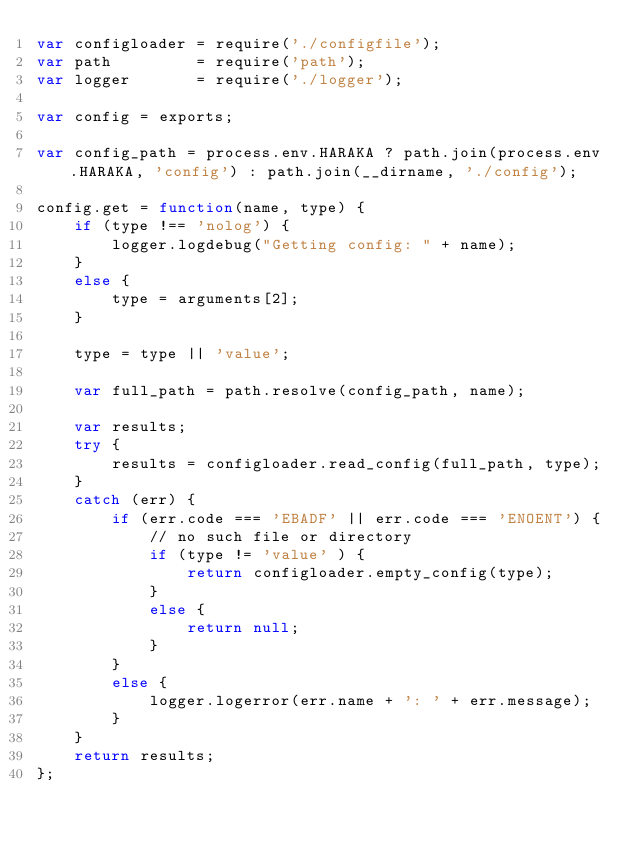Convert code to text. <code><loc_0><loc_0><loc_500><loc_500><_JavaScript_>var configloader = require('./configfile');
var path         = require('path');
var logger       = require('./logger');

var config = exports;

var config_path = process.env.HARAKA ? path.join(process.env.HARAKA, 'config') : path.join(__dirname, './config');

config.get = function(name, type) {
    if (type !== 'nolog') {
        logger.logdebug("Getting config: " + name);
    }
    else {
        type = arguments[2];
    }
    
    type = type || 'value';
    
    var full_path = path.resolve(config_path, name);
    
    var results;
    try {
        results = configloader.read_config(full_path, type);
    }
    catch (err) {
        if (err.code === 'EBADF' || err.code === 'ENOENT') {
            // no such file or directory
            if (type != 'value' ) {
                return configloader.empty_config(type);
            }
            else {
                return null;
            }
        }
        else {
            logger.logerror(err.name + ': ' + err.message);
        }
    }
    return results;
};
</code> 